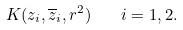<formula> <loc_0><loc_0><loc_500><loc_500>K ( z _ { i } , \overline { z } _ { i } , r ^ { 2 } ) \quad i = 1 , 2 .</formula> 